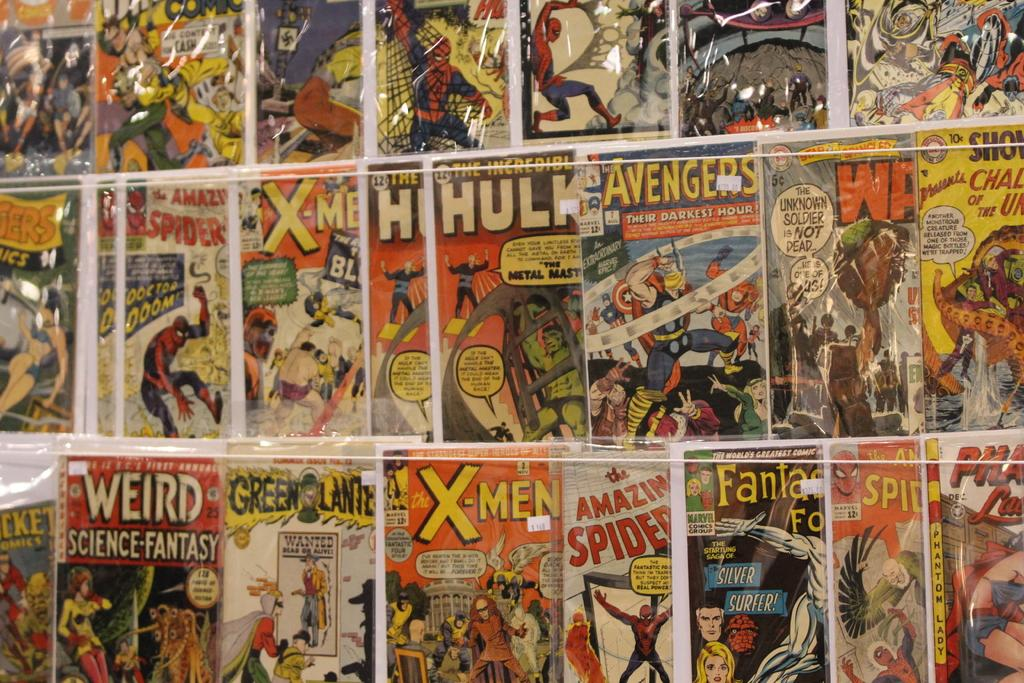What type of reading material is present in the image? There are comic books in the image. How are the comic books arranged in the image? The comic books are kept one beside another. Can you see a kitten playing in the garden in the image? There is no garden or kitten present in the image; it only features comic books arranged one beside another. 